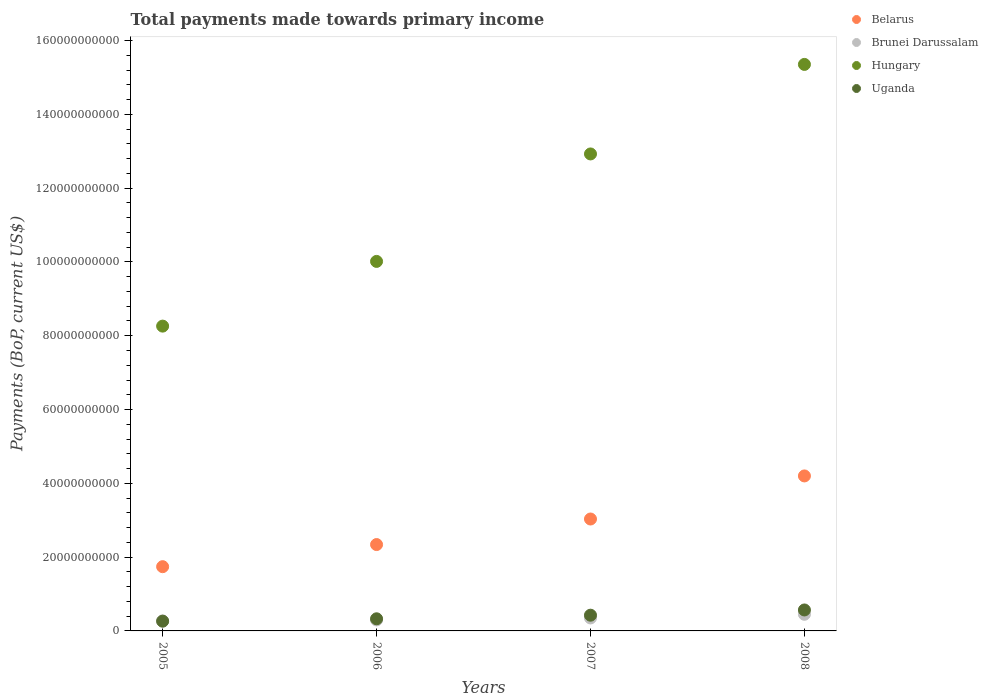What is the total payments made towards primary income in Belarus in 2008?
Offer a terse response. 4.20e+1. Across all years, what is the maximum total payments made towards primary income in Belarus?
Provide a succinct answer. 4.20e+1. Across all years, what is the minimum total payments made towards primary income in Hungary?
Offer a terse response. 8.26e+1. What is the total total payments made towards primary income in Brunei Darussalam in the graph?
Your answer should be very brief. 1.37e+1. What is the difference between the total payments made towards primary income in Belarus in 2007 and that in 2008?
Keep it short and to the point. -1.17e+1. What is the difference between the total payments made towards primary income in Uganda in 2006 and the total payments made towards primary income in Belarus in 2005?
Make the answer very short. -1.41e+1. What is the average total payments made towards primary income in Brunei Darussalam per year?
Provide a succinct answer. 3.43e+09. In the year 2007, what is the difference between the total payments made towards primary income in Brunei Darussalam and total payments made towards primary income in Hungary?
Keep it short and to the point. -1.26e+11. What is the ratio of the total payments made towards primary income in Uganda in 2006 to that in 2007?
Keep it short and to the point. 0.77. Is the difference between the total payments made towards primary income in Brunei Darussalam in 2005 and 2008 greater than the difference between the total payments made towards primary income in Hungary in 2005 and 2008?
Your response must be concise. Yes. What is the difference between the highest and the second highest total payments made towards primary income in Brunei Darussalam?
Give a very brief answer. 9.95e+08. What is the difference between the highest and the lowest total payments made towards primary income in Belarus?
Keep it short and to the point. 2.46e+1. In how many years, is the total payments made towards primary income in Hungary greater than the average total payments made towards primary income in Hungary taken over all years?
Ensure brevity in your answer.  2. Is the sum of the total payments made towards primary income in Belarus in 2006 and 2008 greater than the maximum total payments made towards primary income in Uganda across all years?
Provide a short and direct response. Yes. Does the total payments made towards primary income in Hungary monotonically increase over the years?
Keep it short and to the point. Yes. How many years are there in the graph?
Provide a succinct answer. 4. What is the difference between two consecutive major ticks on the Y-axis?
Ensure brevity in your answer.  2.00e+1. Does the graph contain any zero values?
Give a very brief answer. No. Does the graph contain grids?
Ensure brevity in your answer.  No. Where does the legend appear in the graph?
Keep it short and to the point. Top right. How are the legend labels stacked?
Ensure brevity in your answer.  Vertical. What is the title of the graph?
Your response must be concise. Total payments made towards primary income. Does "Croatia" appear as one of the legend labels in the graph?
Ensure brevity in your answer.  No. What is the label or title of the X-axis?
Your answer should be compact. Years. What is the label or title of the Y-axis?
Your response must be concise. Payments (BoP, current US$). What is the Payments (BoP, current US$) of Belarus in 2005?
Make the answer very short. 1.74e+1. What is the Payments (BoP, current US$) of Brunei Darussalam in 2005?
Provide a succinct answer. 2.71e+09. What is the Payments (BoP, current US$) in Hungary in 2005?
Ensure brevity in your answer.  8.26e+1. What is the Payments (BoP, current US$) of Uganda in 2005?
Ensure brevity in your answer.  2.64e+09. What is the Payments (BoP, current US$) of Belarus in 2006?
Make the answer very short. 2.34e+1. What is the Payments (BoP, current US$) in Brunei Darussalam in 2006?
Keep it short and to the point. 2.98e+09. What is the Payments (BoP, current US$) in Hungary in 2006?
Your answer should be compact. 1.00e+11. What is the Payments (BoP, current US$) of Uganda in 2006?
Give a very brief answer. 3.29e+09. What is the Payments (BoP, current US$) in Belarus in 2007?
Provide a succinct answer. 3.03e+1. What is the Payments (BoP, current US$) of Brunei Darussalam in 2007?
Keep it short and to the point. 3.51e+09. What is the Payments (BoP, current US$) in Hungary in 2007?
Your answer should be very brief. 1.29e+11. What is the Payments (BoP, current US$) of Uganda in 2007?
Give a very brief answer. 4.26e+09. What is the Payments (BoP, current US$) in Belarus in 2008?
Your answer should be compact. 4.20e+1. What is the Payments (BoP, current US$) of Brunei Darussalam in 2008?
Provide a succinct answer. 4.51e+09. What is the Payments (BoP, current US$) in Hungary in 2008?
Keep it short and to the point. 1.54e+11. What is the Payments (BoP, current US$) of Uganda in 2008?
Ensure brevity in your answer.  5.68e+09. Across all years, what is the maximum Payments (BoP, current US$) of Belarus?
Give a very brief answer. 4.20e+1. Across all years, what is the maximum Payments (BoP, current US$) in Brunei Darussalam?
Your answer should be compact. 4.51e+09. Across all years, what is the maximum Payments (BoP, current US$) of Hungary?
Ensure brevity in your answer.  1.54e+11. Across all years, what is the maximum Payments (BoP, current US$) in Uganda?
Give a very brief answer. 5.68e+09. Across all years, what is the minimum Payments (BoP, current US$) in Belarus?
Ensure brevity in your answer.  1.74e+1. Across all years, what is the minimum Payments (BoP, current US$) of Brunei Darussalam?
Keep it short and to the point. 2.71e+09. Across all years, what is the minimum Payments (BoP, current US$) of Hungary?
Offer a terse response. 8.26e+1. Across all years, what is the minimum Payments (BoP, current US$) in Uganda?
Ensure brevity in your answer.  2.64e+09. What is the total Payments (BoP, current US$) of Belarus in the graph?
Make the answer very short. 1.13e+11. What is the total Payments (BoP, current US$) in Brunei Darussalam in the graph?
Your answer should be very brief. 1.37e+1. What is the total Payments (BoP, current US$) in Hungary in the graph?
Give a very brief answer. 4.66e+11. What is the total Payments (BoP, current US$) in Uganda in the graph?
Provide a short and direct response. 1.59e+1. What is the difference between the Payments (BoP, current US$) of Belarus in 2005 and that in 2006?
Provide a succinct answer. -6.00e+09. What is the difference between the Payments (BoP, current US$) in Brunei Darussalam in 2005 and that in 2006?
Keep it short and to the point. -2.72e+08. What is the difference between the Payments (BoP, current US$) in Hungary in 2005 and that in 2006?
Your answer should be very brief. -1.75e+1. What is the difference between the Payments (BoP, current US$) of Uganda in 2005 and that in 2006?
Your answer should be compact. -6.45e+08. What is the difference between the Payments (BoP, current US$) in Belarus in 2005 and that in 2007?
Offer a terse response. -1.29e+1. What is the difference between the Payments (BoP, current US$) of Brunei Darussalam in 2005 and that in 2007?
Make the answer very short. -8.03e+08. What is the difference between the Payments (BoP, current US$) of Hungary in 2005 and that in 2007?
Your answer should be very brief. -4.67e+1. What is the difference between the Payments (BoP, current US$) of Uganda in 2005 and that in 2007?
Ensure brevity in your answer.  -1.62e+09. What is the difference between the Payments (BoP, current US$) in Belarus in 2005 and that in 2008?
Provide a succinct answer. -2.46e+1. What is the difference between the Payments (BoP, current US$) in Brunei Darussalam in 2005 and that in 2008?
Give a very brief answer. -1.80e+09. What is the difference between the Payments (BoP, current US$) of Hungary in 2005 and that in 2008?
Offer a terse response. -7.09e+1. What is the difference between the Payments (BoP, current US$) in Uganda in 2005 and that in 2008?
Keep it short and to the point. -3.04e+09. What is the difference between the Payments (BoP, current US$) in Belarus in 2006 and that in 2007?
Make the answer very short. -6.92e+09. What is the difference between the Payments (BoP, current US$) of Brunei Darussalam in 2006 and that in 2007?
Keep it short and to the point. -5.30e+08. What is the difference between the Payments (BoP, current US$) of Hungary in 2006 and that in 2007?
Your answer should be very brief. -2.91e+1. What is the difference between the Payments (BoP, current US$) in Uganda in 2006 and that in 2007?
Provide a succinct answer. -9.77e+08. What is the difference between the Payments (BoP, current US$) of Belarus in 2006 and that in 2008?
Keep it short and to the point. -1.86e+1. What is the difference between the Payments (BoP, current US$) of Brunei Darussalam in 2006 and that in 2008?
Keep it short and to the point. -1.52e+09. What is the difference between the Payments (BoP, current US$) in Hungary in 2006 and that in 2008?
Offer a terse response. -5.34e+1. What is the difference between the Payments (BoP, current US$) in Uganda in 2006 and that in 2008?
Ensure brevity in your answer.  -2.39e+09. What is the difference between the Payments (BoP, current US$) in Belarus in 2007 and that in 2008?
Your answer should be very brief. -1.17e+1. What is the difference between the Payments (BoP, current US$) in Brunei Darussalam in 2007 and that in 2008?
Provide a succinct answer. -9.95e+08. What is the difference between the Payments (BoP, current US$) of Hungary in 2007 and that in 2008?
Your response must be concise. -2.43e+1. What is the difference between the Payments (BoP, current US$) of Uganda in 2007 and that in 2008?
Your response must be concise. -1.42e+09. What is the difference between the Payments (BoP, current US$) of Belarus in 2005 and the Payments (BoP, current US$) of Brunei Darussalam in 2006?
Ensure brevity in your answer.  1.44e+1. What is the difference between the Payments (BoP, current US$) in Belarus in 2005 and the Payments (BoP, current US$) in Hungary in 2006?
Your response must be concise. -8.27e+1. What is the difference between the Payments (BoP, current US$) of Belarus in 2005 and the Payments (BoP, current US$) of Uganda in 2006?
Your answer should be compact. 1.41e+1. What is the difference between the Payments (BoP, current US$) of Brunei Darussalam in 2005 and the Payments (BoP, current US$) of Hungary in 2006?
Ensure brevity in your answer.  -9.74e+1. What is the difference between the Payments (BoP, current US$) of Brunei Darussalam in 2005 and the Payments (BoP, current US$) of Uganda in 2006?
Offer a very short reply. -5.74e+08. What is the difference between the Payments (BoP, current US$) in Hungary in 2005 and the Payments (BoP, current US$) in Uganda in 2006?
Provide a short and direct response. 7.93e+1. What is the difference between the Payments (BoP, current US$) of Belarus in 2005 and the Payments (BoP, current US$) of Brunei Darussalam in 2007?
Offer a terse response. 1.39e+1. What is the difference between the Payments (BoP, current US$) in Belarus in 2005 and the Payments (BoP, current US$) in Hungary in 2007?
Ensure brevity in your answer.  -1.12e+11. What is the difference between the Payments (BoP, current US$) in Belarus in 2005 and the Payments (BoP, current US$) in Uganda in 2007?
Provide a succinct answer. 1.31e+1. What is the difference between the Payments (BoP, current US$) in Brunei Darussalam in 2005 and the Payments (BoP, current US$) in Hungary in 2007?
Keep it short and to the point. -1.27e+11. What is the difference between the Payments (BoP, current US$) in Brunei Darussalam in 2005 and the Payments (BoP, current US$) in Uganda in 2007?
Make the answer very short. -1.55e+09. What is the difference between the Payments (BoP, current US$) of Hungary in 2005 and the Payments (BoP, current US$) of Uganda in 2007?
Your response must be concise. 7.83e+1. What is the difference between the Payments (BoP, current US$) in Belarus in 2005 and the Payments (BoP, current US$) in Brunei Darussalam in 2008?
Offer a terse response. 1.29e+1. What is the difference between the Payments (BoP, current US$) of Belarus in 2005 and the Payments (BoP, current US$) of Hungary in 2008?
Your response must be concise. -1.36e+11. What is the difference between the Payments (BoP, current US$) in Belarus in 2005 and the Payments (BoP, current US$) in Uganda in 2008?
Offer a very short reply. 1.17e+1. What is the difference between the Payments (BoP, current US$) in Brunei Darussalam in 2005 and the Payments (BoP, current US$) in Hungary in 2008?
Give a very brief answer. -1.51e+11. What is the difference between the Payments (BoP, current US$) in Brunei Darussalam in 2005 and the Payments (BoP, current US$) in Uganda in 2008?
Your response must be concise. -2.97e+09. What is the difference between the Payments (BoP, current US$) of Hungary in 2005 and the Payments (BoP, current US$) of Uganda in 2008?
Provide a short and direct response. 7.69e+1. What is the difference between the Payments (BoP, current US$) of Belarus in 2006 and the Payments (BoP, current US$) of Brunei Darussalam in 2007?
Your answer should be very brief. 1.99e+1. What is the difference between the Payments (BoP, current US$) of Belarus in 2006 and the Payments (BoP, current US$) of Hungary in 2007?
Provide a short and direct response. -1.06e+11. What is the difference between the Payments (BoP, current US$) of Belarus in 2006 and the Payments (BoP, current US$) of Uganda in 2007?
Offer a terse response. 1.91e+1. What is the difference between the Payments (BoP, current US$) in Brunei Darussalam in 2006 and the Payments (BoP, current US$) in Hungary in 2007?
Give a very brief answer. -1.26e+11. What is the difference between the Payments (BoP, current US$) of Brunei Darussalam in 2006 and the Payments (BoP, current US$) of Uganda in 2007?
Offer a terse response. -1.28e+09. What is the difference between the Payments (BoP, current US$) in Hungary in 2006 and the Payments (BoP, current US$) in Uganda in 2007?
Your response must be concise. 9.59e+1. What is the difference between the Payments (BoP, current US$) in Belarus in 2006 and the Payments (BoP, current US$) in Brunei Darussalam in 2008?
Your response must be concise. 1.89e+1. What is the difference between the Payments (BoP, current US$) of Belarus in 2006 and the Payments (BoP, current US$) of Hungary in 2008?
Make the answer very short. -1.30e+11. What is the difference between the Payments (BoP, current US$) of Belarus in 2006 and the Payments (BoP, current US$) of Uganda in 2008?
Provide a short and direct response. 1.77e+1. What is the difference between the Payments (BoP, current US$) of Brunei Darussalam in 2006 and the Payments (BoP, current US$) of Hungary in 2008?
Make the answer very short. -1.51e+11. What is the difference between the Payments (BoP, current US$) in Brunei Darussalam in 2006 and the Payments (BoP, current US$) in Uganda in 2008?
Your response must be concise. -2.70e+09. What is the difference between the Payments (BoP, current US$) in Hungary in 2006 and the Payments (BoP, current US$) in Uganda in 2008?
Make the answer very short. 9.45e+1. What is the difference between the Payments (BoP, current US$) of Belarus in 2007 and the Payments (BoP, current US$) of Brunei Darussalam in 2008?
Your answer should be very brief. 2.58e+1. What is the difference between the Payments (BoP, current US$) of Belarus in 2007 and the Payments (BoP, current US$) of Hungary in 2008?
Offer a terse response. -1.23e+11. What is the difference between the Payments (BoP, current US$) in Belarus in 2007 and the Payments (BoP, current US$) in Uganda in 2008?
Your answer should be compact. 2.47e+1. What is the difference between the Payments (BoP, current US$) in Brunei Darussalam in 2007 and the Payments (BoP, current US$) in Hungary in 2008?
Offer a terse response. -1.50e+11. What is the difference between the Payments (BoP, current US$) of Brunei Darussalam in 2007 and the Payments (BoP, current US$) of Uganda in 2008?
Your answer should be very brief. -2.17e+09. What is the difference between the Payments (BoP, current US$) in Hungary in 2007 and the Payments (BoP, current US$) in Uganda in 2008?
Keep it short and to the point. 1.24e+11. What is the average Payments (BoP, current US$) of Belarus per year?
Provide a succinct answer. 2.83e+1. What is the average Payments (BoP, current US$) of Brunei Darussalam per year?
Your response must be concise. 3.43e+09. What is the average Payments (BoP, current US$) of Hungary per year?
Give a very brief answer. 1.16e+11. What is the average Payments (BoP, current US$) in Uganda per year?
Make the answer very short. 3.97e+09. In the year 2005, what is the difference between the Payments (BoP, current US$) of Belarus and Payments (BoP, current US$) of Brunei Darussalam?
Make the answer very short. 1.47e+1. In the year 2005, what is the difference between the Payments (BoP, current US$) in Belarus and Payments (BoP, current US$) in Hungary?
Offer a very short reply. -6.52e+1. In the year 2005, what is the difference between the Payments (BoP, current US$) in Belarus and Payments (BoP, current US$) in Uganda?
Offer a terse response. 1.48e+1. In the year 2005, what is the difference between the Payments (BoP, current US$) in Brunei Darussalam and Payments (BoP, current US$) in Hungary?
Give a very brief answer. -7.99e+1. In the year 2005, what is the difference between the Payments (BoP, current US$) in Brunei Darussalam and Payments (BoP, current US$) in Uganda?
Provide a short and direct response. 7.08e+07. In the year 2005, what is the difference between the Payments (BoP, current US$) of Hungary and Payments (BoP, current US$) of Uganda?
Make the answer very short. 8.00e+1. In the year 2006, what is the difference between the Payments (BoP, current US$) in Belarus and Payments (BoP, current US$) in Brunei Darussalam?
Your answer should be compact. 2.04e+1. In the year 2006, what is the difference between the Payments (BoP, current US$) of Belarus and Payments (BoP, current US$) of Hungary?
Your answer should be very brief. -7.67e+1. In the year 2006, what is the difference between the Payments (BoP, current US$) of Belarus and Payments (BoP, current US$) of Uganda?
Your response must be concise. 2.01e+1. In the year 2006, what is the difference between the Payments (BoP, current US$) of Brunei Darussalam and Payments (BoP, current US$) of Hungary?
Give a very brief answer. -9.72e+1. In the year 2006, what is the difference between the Payments (BoP, current US$) in Brunei Darussalam and Payments (BoP, current US$) in Uganda?
Give a very brief answer. -3.02e+08. In the year 2006, what is the difference between the Payments (BoP, current US$) in Hungary and Payments (BoP, current US$) in Uganda?
Offer a terse response. 9.69e+1. In the year 2007, what is the difference between the Payments (BoP, current US$) in Belarus and Payments (BoP, current US$) in Brunei Darussalam?
Your answer should be very brief. 2.68e+1. In the year 2007, what is the difference between the Payments (BoP, current US$) in Belarus and Payments (BoP, current US$) in Hungary?
Ensure brevity in your answer.  -9.89e+1. In the year 2007, what is the difference between the Payments (BoP, current US$) of Belarus and Payments (BoP, current US$) of Uganda?
Your answer should be compact. 2.61e+1. In the year 2007, what is the difference between the Payments (BoP, current US$) of Brunei Darussalam and Payments (BoP, current US$) of Hungary?
Keep it short and to the point. -1.26e+11. In the year 2007, what is the difference between the Payments (BoP, current US$) in Brunei Darussalam and Payments (BoP, current US$) in Uganda?
Ensure brevity in your answer.  -7.49e+08. In the year 2007, what is the difference between the Payments (BoP, current US$) in Hungary and Payments (BoP, current US$) in Uganda?
Give a very brief answer. 1.25e+11. In the year 2008, what is the difference between the Payments (BoP, current US$) of Belarus and Payments (BoP, current US$) of Brunei Darussalam?
Provide a succinct answer. 3.75e+1. In the year 2008, what is the difference between the Payments (BoP, current US$) of Belarus and Payments (BoP, current US$) of Hungary?
Keep it short and to the point. -1.12e+11. In the year 2008, what is the difference between the Payments (BoP, current US$) of Belarus and Payments (BoP, current US$) of Uganda?
Offer a very short reply. 3.63e+1. In the year 2008, what is the difference between the Payments (BoP, current US$) in Brunei Darussalam and Payments (BoP, current US$) in Hungary?
Provide a succinct answer. -1.49e+11. In the year 2008, what is the difference between the Payments (BoP, current US$) in Brunei Darussalam and Payments (BoP, current US$) in Uganda?
Provide a succinct answer. -1.17e+09. In the year 2008, what is the difference between the Payments (BoP, current US$) in Hungary and Payments (BoP, current US$) in Uganda?
Give a very brief answer. 1.48e+11. What is the ratio of the Payments (BoP, current US$) in Belarus in 2005 to that in 2006?
Your answer should be very brief. 0.74. What is the ratio of the Payments (BoP, current US$) of Brunei Darussalam in 2005 to that in 2006?
Provide a short and direct response. 0.91. What is the ratio of the Payments (BoP, current US$) in Hungary in 2005 to that in 2006?
Your answer should be compact. 0.82. What is the ratio of the Payments (BoP, current US$) of Uganda in 2005 to that in 2006?
Your response must be concise. 0.8. What is the ratio of the Payments (BoP, current US$) of Belarus in 2005 to that in 2007?
Offer a very short reply. 0.57. What is the ratio of the Payments (BoP, current US$) of Brunei Darussalam in 2005 to that in 2007?
Provide a succinct answer. 0.77. What is the ratio of the Payments (BoP, current US$) of Hungary in 2005 to that in 2007?
Keep it short and to the point. 0.64. What is the ratio of the Payments (BoP, current US$) of Uganda in 2005 to that in 2007?
Make the answer very short. 0.62. What is the ratio of the Payments (BoP, current US$) in Belarus in 2005 to that in 2008?
Give a very brief answer. 0.41. What is the ratio of the Payments (BoP, current US$) in Brunei Darussalam in 2005 to that in 2008?
Offer a very short reply. 0.6. What is the ratio of the Payments (BoP, current US$) of Hungary in 2005 to that in 2008?
Offer a terse response. 0.54. What is the ratio of the Payments (BoP, current US$) of Uganda in 2005 to that in 2008?
Provide a short and direct response. 0.47. What is the ratio of the Payments (BoP, current US$) of Belarus in 2006 to that in 2007?
Provide a short and direct response. 0.77. What is the ratio of the Payments (BoP, current US$) in Brunei Darussalam in 2006 to that in 2007?
Keep it short and to the point. 0.85. What is the ratio of the Payments (BoP, current US$) in Hungary in 2006 to that in 2007?
Make the answer very short. 0.77. What is the ratio of the Payments (BoP, current US$) of Uganda in 2006 to that in 2007?
Keep it short and to the point. 0.77. What is the ratio of the Payments (BoP, current US$) in Belarus in 2006 to that in 2008?
Offer a terse response. 0.56. What is the ratio of the Payments (BoP, current US$) in Brunei Darussalam in 2006 to that in 2008?
Provide a succinct answer. 0.66. What is the ratio of the Payments (BoP, current US$) of Hungary in 2006 to that in 2008?
Provide a succinct answer. 0.65. What is the ratio of the Payments (BoP, current US$) in Uganda in 2006 to that in 2008?
Your response must be concise. 0.58. What is the ratio of the Payments (BoP, current US$) of Belarus in 2007 to that in 2008?
Give a very brief answer. 0.72. What is the ratio of the Payments (BoP, current US$) of Brunei Darussalam in 2007 to that in 2008?
Provide a succinct answer. 0.78. What is the ratio of the Payments (BoP, current US$) in Hungary in 2007 to that in 2008?
Your answer should be compact. 0.84. What is the ratio of the Payments (BoP, current US$) in Uganda in 2007 to that in 2008?
Your answer should be very brief. 0.75. What is the difference between the highest and the second highest Payments (BoP, current US$) of Belarus?
Provide a short and direct response. 1.17e+1. What is the difference between the highest and the second highest Payments (BoP, current US$) in Brunei Darussalam?
Provide a succinct answer. 9.95e+08. What is the difference between the highest and the second highest Payments (BoP, current US$) of Hungary?
Keep it short and to the point. 2.43e+1. What is the difference between the highest and the second highest Payments (BoP, current US$) of Uganda?
Give a very brief answer. 1.42e+09. What is the difference between the highest and the lowest Payments (BoP, current US$) in Belarus?
Provide a succinct answer. 2.46e+1. What is the difference between the highest and the lowest Payments (BoP, current US$) of Brunei Darussalam?
Provide a short and direct response. 1.80e+09. What is the difference between the highest and the lowest Payments (BoP, current US$) in Hungary?
Keep it short and to the point. 7.09e+1. What is the difference between the highest and the lowest Payments (BoP, current US$) in Uganda?
Ensure brevity in your answer.  3.04e+09. 